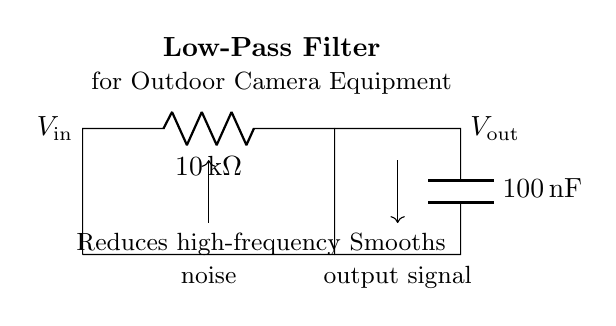What is the resistance value in this circuit? The resistance component labeled R has a value of 10 kΩ. It is clearly marked in the circuit diagram next to the resistor symbol.
Answer: 10 kΩ What is the capacitance value in this circuit? The capacitance component labeled C has a value of 100 nF. This is indicated in the circuit diagram just next to the capacitor symbol.
Answer: 100 nF What does the low-pass filter do? The circuit is designed to reduce high-frequency noise, as indicated in the text near the circuit diagram. This functionality allows for a smoother output signal by filtering out unwanted frequencies.
Answer: Reduces high-frequency noise What is the relationship between input and output voltage? The output voltage V_out is influenced by the input voltage V_in, and the circuit is set up to smooth V_out compared to V_in, allowing it to maintain lower frequencies. This indicates a dependence of V_out on V_in through the filter action.
Answer: V_out smooths V_in What is the type of filter represented in this circuit? The circuit diagram depicts a low-pass filter, which is specifically designed to allow low-frequency signals to pass while attenuating high-frequency signals, as described in the label of the diagram.
Answer: Low-pass filter What happens to the output signal after filtering? After filtering, the output signal is smoothed, meaning that it exhibits fewer fluctuations and reduced high-frequency noise, which is important for maintaining a cleaner signal in outdoor camera equipment.
Answer: Smooths output signal 